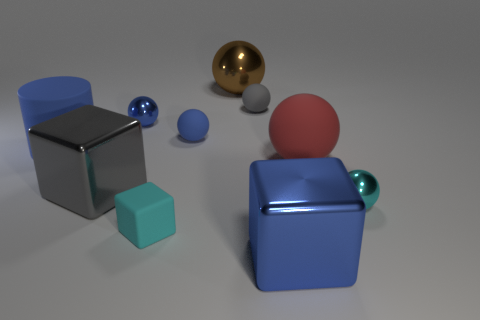Subtract 2 balls. How many balls are left? 4 Subtract all cyan spheres. How many spheres are left? 5 Subtract all small metal balls. How many balls are left? 4 Subtract all cyan spheres. Subtract all red cylinders. How many spheres are left? 5 Subtract all cubes. How many objects are left? 7 Subtract all blue metallic blocks. Subtract all blue metallic cubes. How many objects are left? 8 Add 5 big blue metallic things. How many big blue metallic things are left? 6 Add 5 big balls. How many big balls exist? 7 Subtract 1 cyan spheres. How many objects are left? 9 